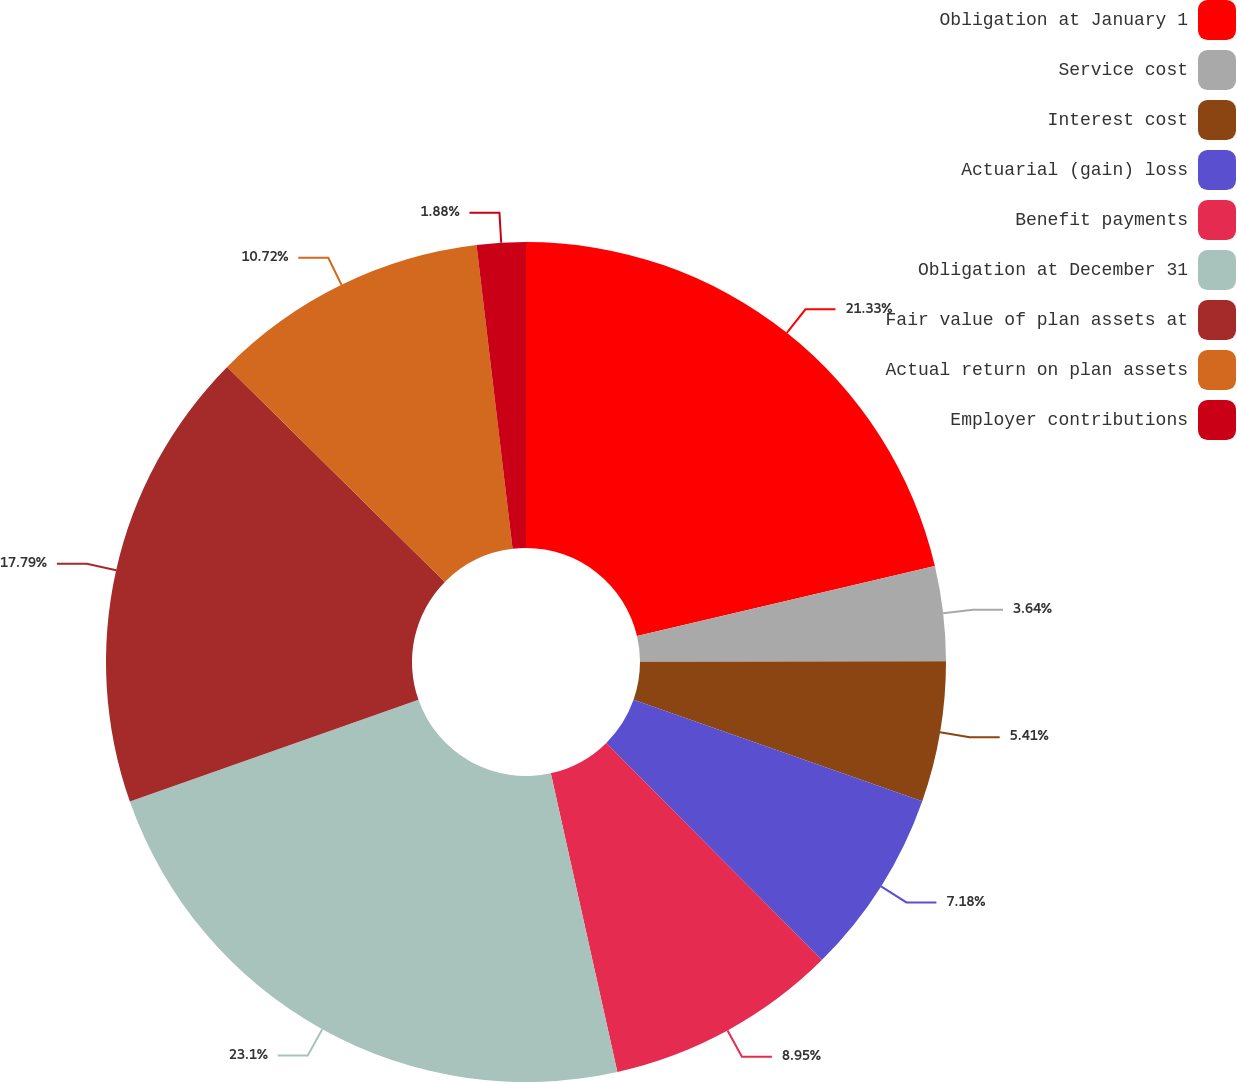Convert chart. <chart><loc_0><loc_0><loc_500><loc_500><pie_chart><fcel>Obligation at January 1<fcel>Service cost<fcel>Interest cost<fcel>Actuarial (gain) loss<fcel>Benefit payments<fcel>Obligation at December 31<fcel>Fair value of plan assets at<fcel>Actual return on plan assets<fcel>Employer contributions<nl><fcel>21.33%<fcel>3.64%<fcel>5.41%<fcel>7.18%<fcel>8.95%<fcel>23.1%<fcel>17.79%<fcel>10.72%<fcel>1.88%<nl></chart> 